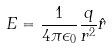<formula> <loc_0><loc_0><loc_500><loc_500>E = \frac { 1 } { 4 \pi \epsilon _ { 0 } } \frac { q } { r ^ { 2 } } \hat { r }</formula> 